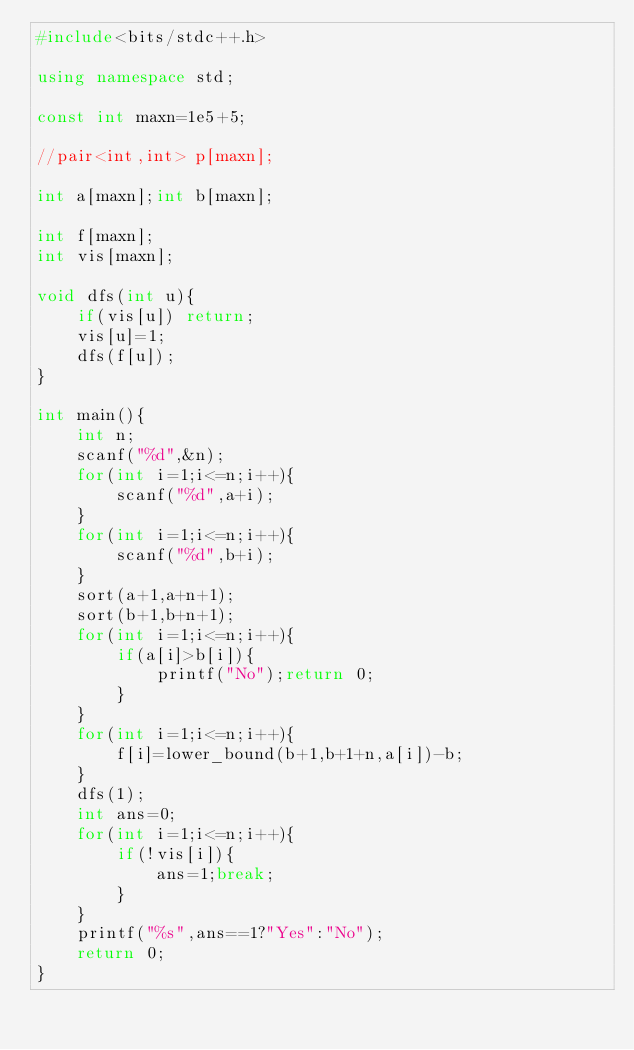Convert code to text. <code><loc_0><loc_0><loc_500><loc_500><_C++_>#include<bits/stdc++.h>

using namespace std;

const int maxn=1e5+5;

//pair<int,int> p[maxn];

int a[maxn];int b[maxn];

int f[maxn];
int vis[maxn];

void dfs(int u){
	if(vis[u]) return;
	vis[u]=1;
	dfs(f[u]);
}

int main(){
	int n;
	scanf("%d",&n);
	for(int i=1;i<=n;i++){
		scanf("%d",a+i);
	}
	for(int i=1;i<=n;i++){
		scanf("%d",b+i);
	}
	sort(a+1,a+n+1);
	sort(b+1,b+n+1);
	for(int i=1;i<=n;i++){
		if(a[i]>b[i]){
			printf("No");return 0;
		}
	}
	for(int i=1;i<=n;i++){
		f[i]=lower_bound(b+1,b+1+n,a[i])-b;
	}
	dfs(1);
	int ans=0;
	for(int i=1;i<=n;i++){
		if(!vis[i]){
			ans=1;break;
		}
	}
	printf("%s",ans==1?"Yes":"No");
	return 0;
}</code> 